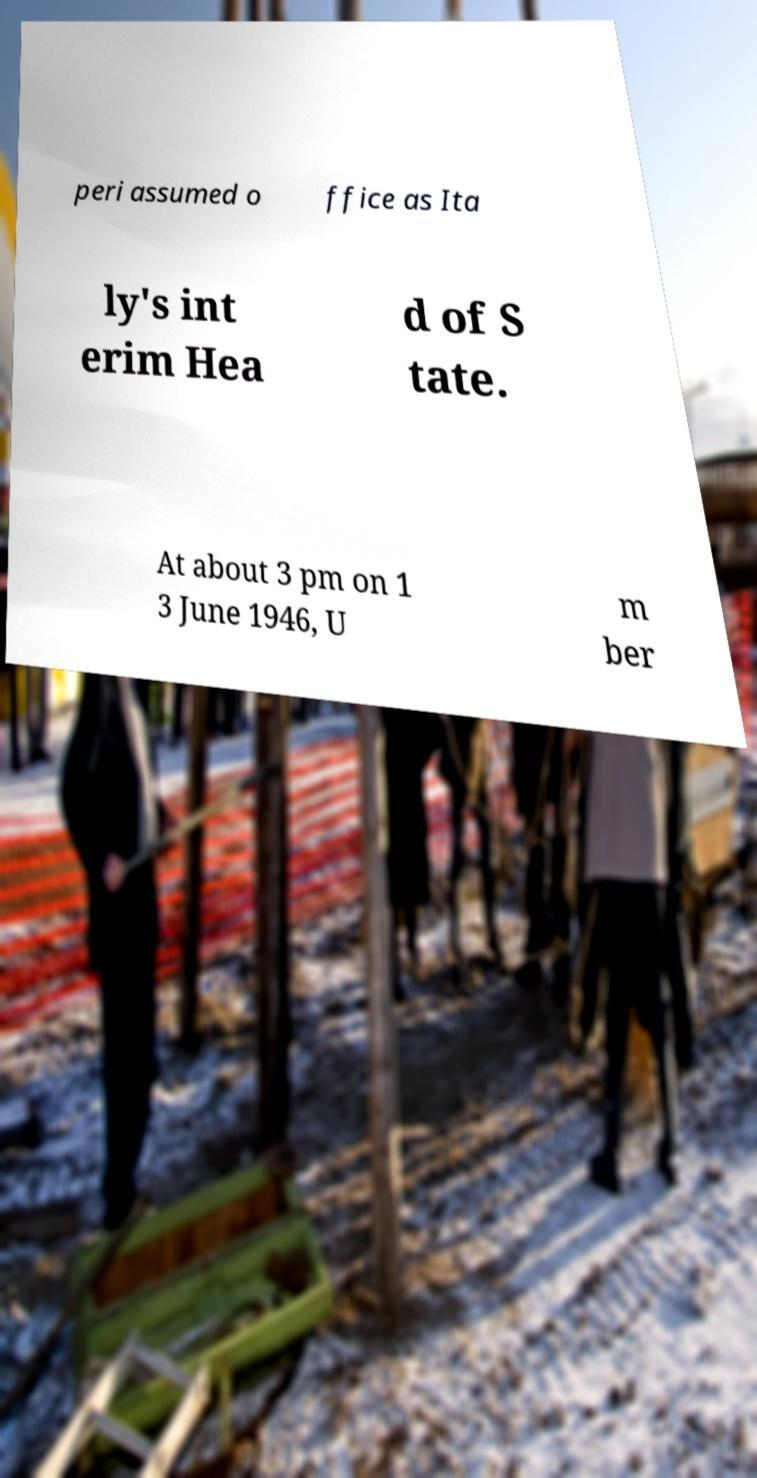Could you extract and type out the text from this image? peri assumed o ffice as Ita ly's int erim Hea d of S tate. At about 3 pm on 1 3 June 1946, U m ber 